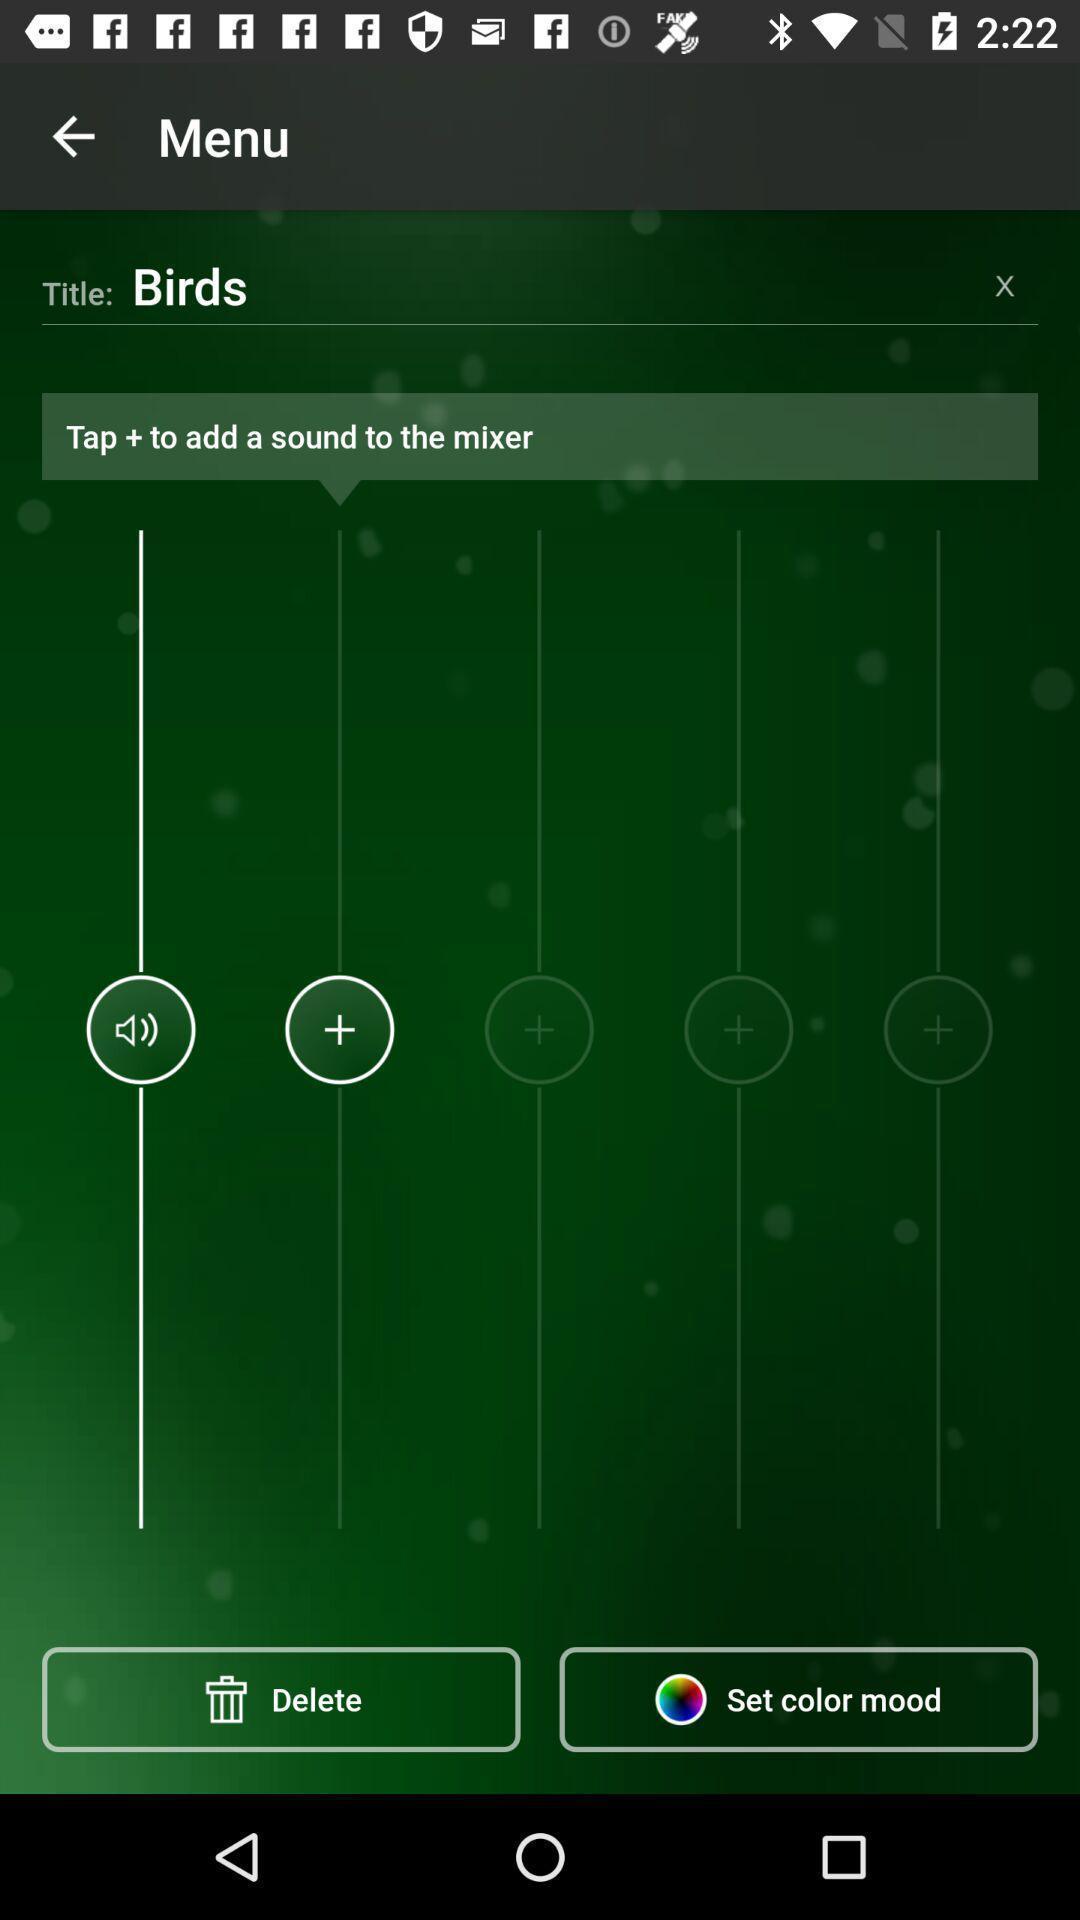Summarize the main components in this picture. Title in menu of the app. 